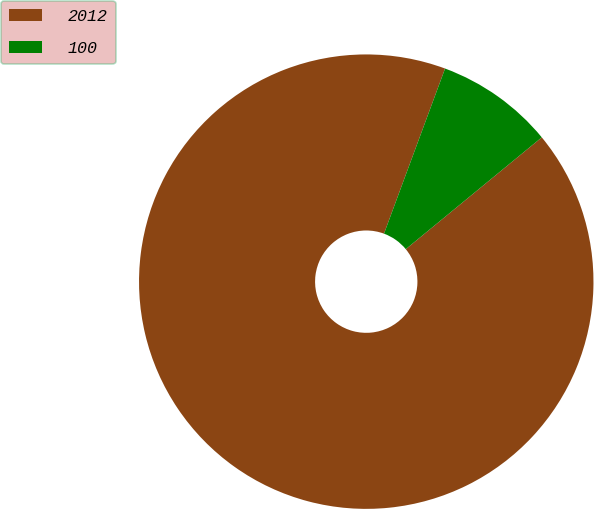Convert chart. <chart><loc_0><loc_0><loc_500><loc_500><pie_chart><fcel>2012<fcel>100<nl><fcel>91.59%<fcel>8.41%<nl></chart> 